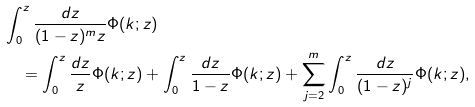Convert formula to latex. <formula><loc_0><loc_0><loc_500><loc_500>& \int _ { 0 } ^ { z } \frac { d z } { ( 1 - z ) ^ { m } z } \Phi ( k ; z ) \\ & \quad = \int _ { 0 } ^ { z } \frac { d z } { z } \Phi ( k ; z ) + \int _ { 0 } ^ { z } \frac { d z } { 1 - z } \Phi ( k ; z ) + \sum _ { j = 2 } ^ { m } \int _ { 0 } ^ { z } \frac { d z } { ( 1 - z ) ^ { j } } \Phi ( k ; z ) ,</formula> 